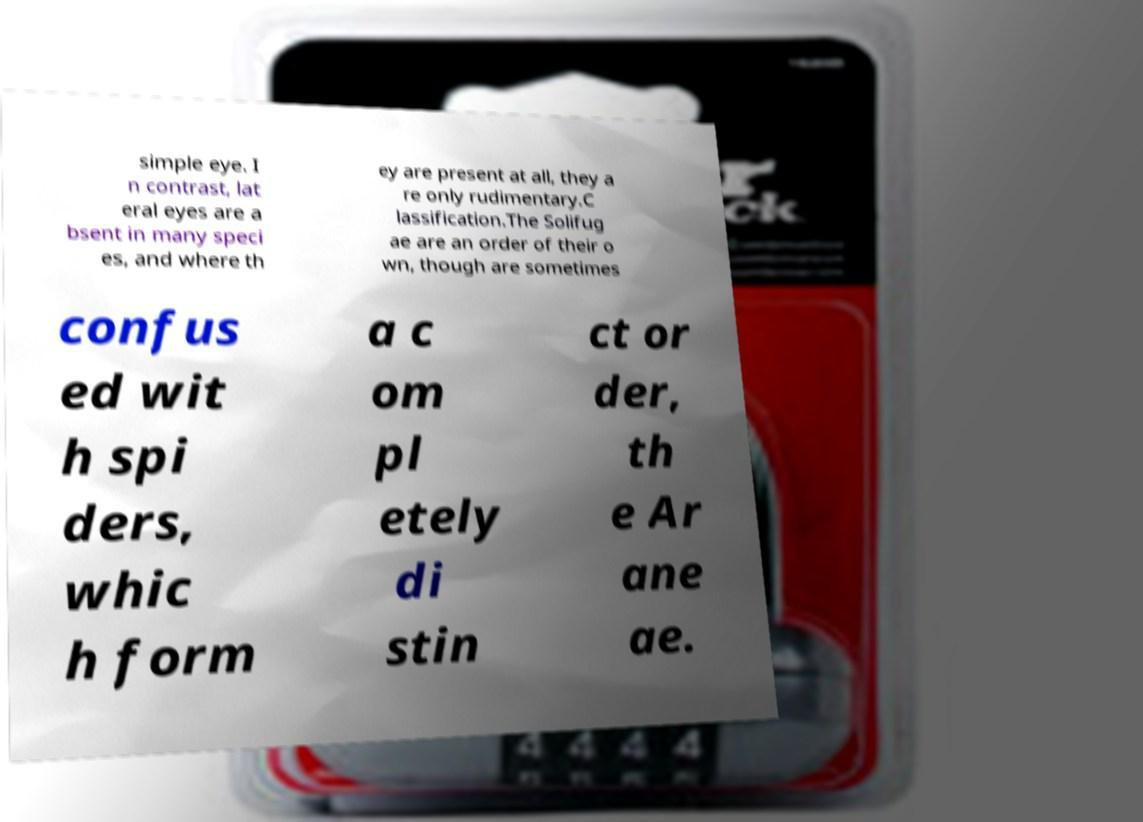Please read and relay the text visible in this image. What does it say? simple eye. I n contrast, lat eral eyes are a bsent in many speci es, and where th ey are present at all, they a re only rudimentary.C lassification.The Solifug ae are an order of their o wn, though are sometimes confus ed wit h spi ders, whic h form a c om pl etely di stin ct or der, th e Ar ane ae. 